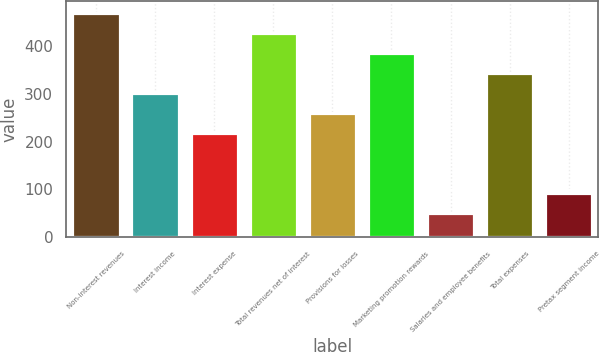Convert chart. <chart><loc_0><loc_0><loc_500><loc_500><bar_chart><fcel>Non-interest revenues<fcel>Interest income<fcel>Interest expense<fcel>Total revenues net of interest<fcel>Provisions for losses<fcel>Marketing promotion rewards<fcel>Salaries and employee benefits<fcel>Total expenses<fcel>Pretax segment income<nl><fcel>469<fcel>301.8<fcel>218.2<fcel>427.2<fcel>260<fcel>385.4<fcel>51<fcel>343.6<fcel>92.8<nl></chart> 